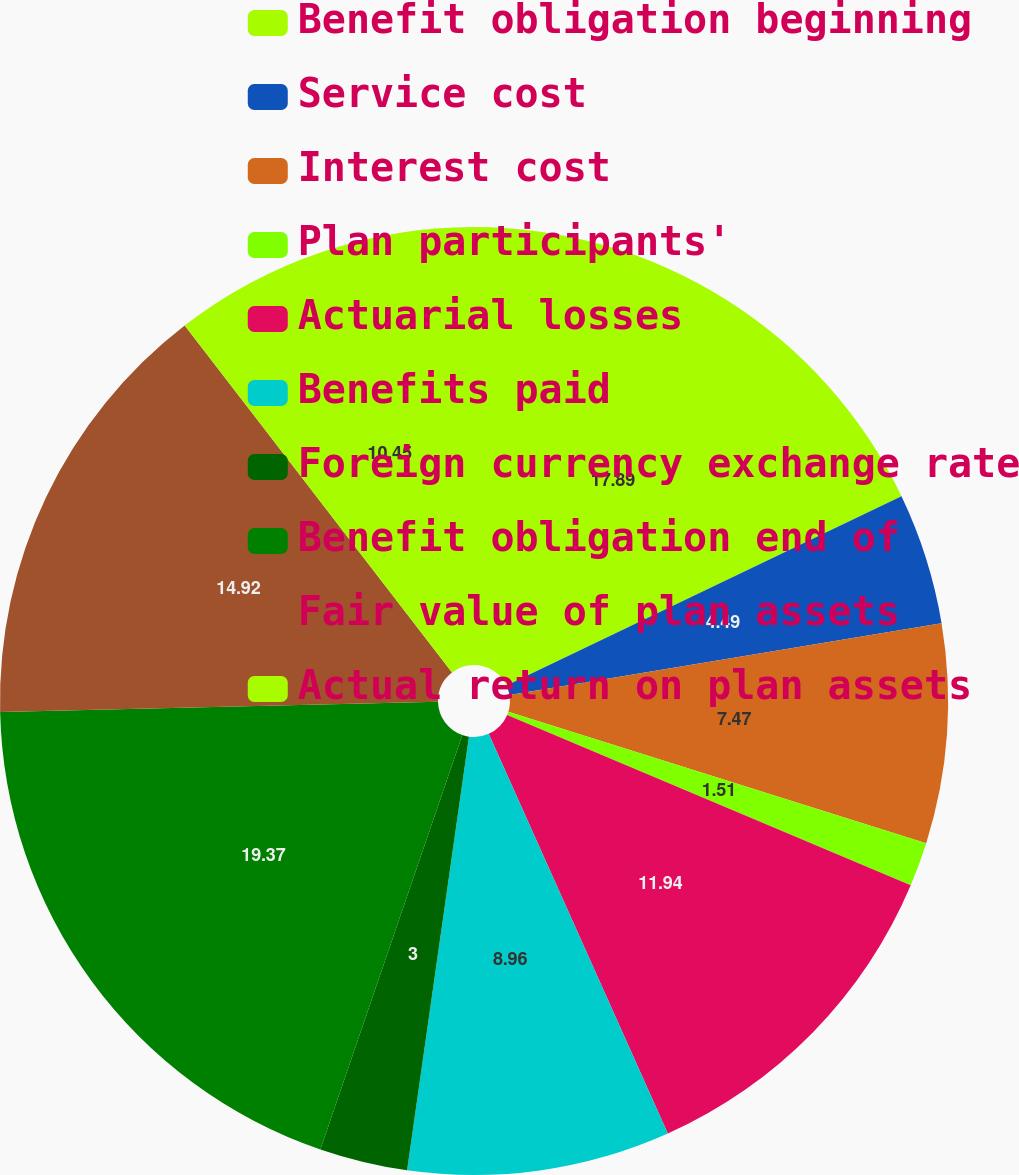Convert chart. <chart><loc_0><loc_0><loc_500><loc_500><pie_chart><fcel>Benefit obligation beginning<fcel>Service cost<fcel>Interest cost<fcel>Plan participants'<fcel>Actuarial losses<fcel>Benefits paid<fcel>Foreign currency exchange rate<fcel>Benefit obligation end of<fcel>Fair value of plan assets<fcel>Actual return on plan assets<nl><fcel>17.89%<fcel>4.49%<fcel>7.47%<fcel>1.51%<fcel>11.94%<fcel>8.96%<fcel>3.0%<fcel>19.38%<fcel>14.92%<fcel>10.45%<nl></chart> 